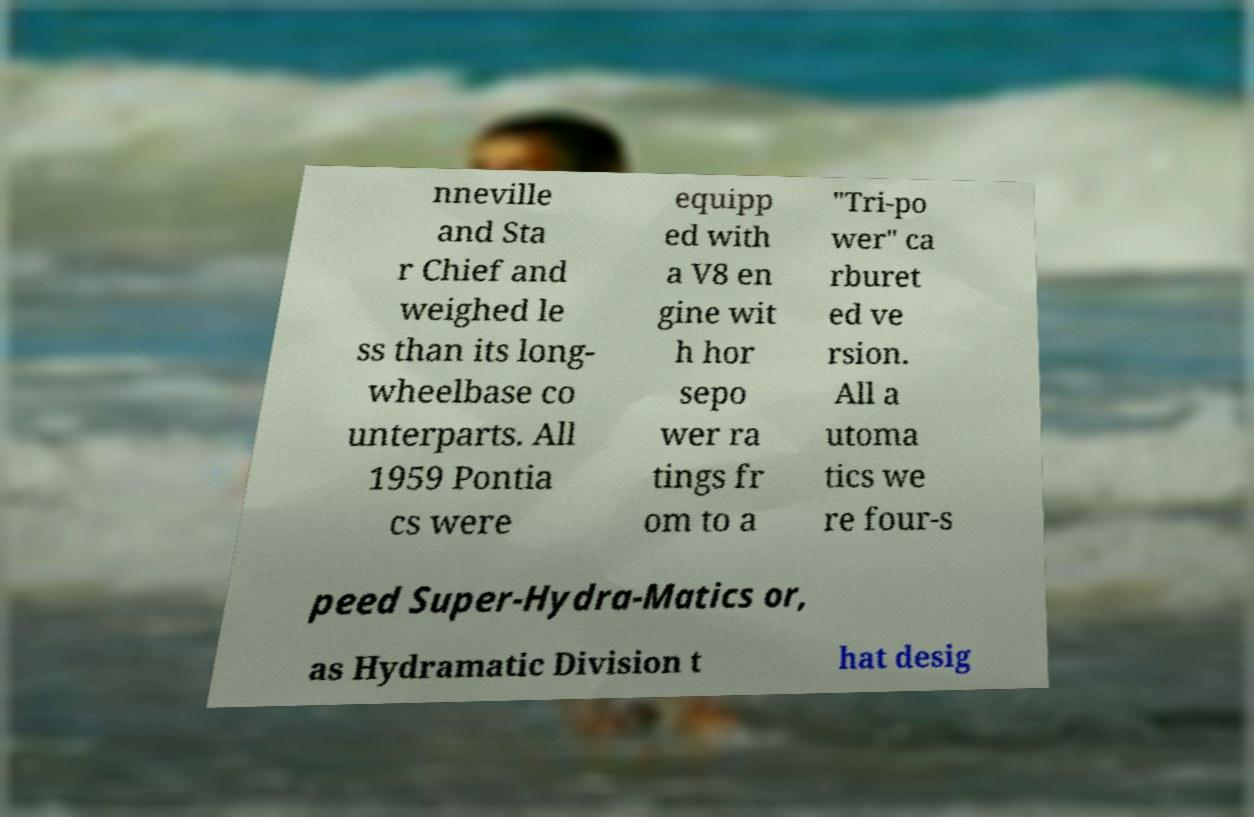Can you read and provide the text displayed in the image?This photo seems to have some interesting text. Can you extract and type it out for me? nneville and Sta r Chief and weighed le ss than its long- wheelbase co unterparts. All 1959 Pontia cs were equipp ed with a V8 en gine wit h hor sepo wer ra tings fr om to a "Tri-po wer" ca rburet ed ve rsion. All a utoma tics we re four-s peed Super-Hydra-Matics or, as Hydramatic Division t hat desig 